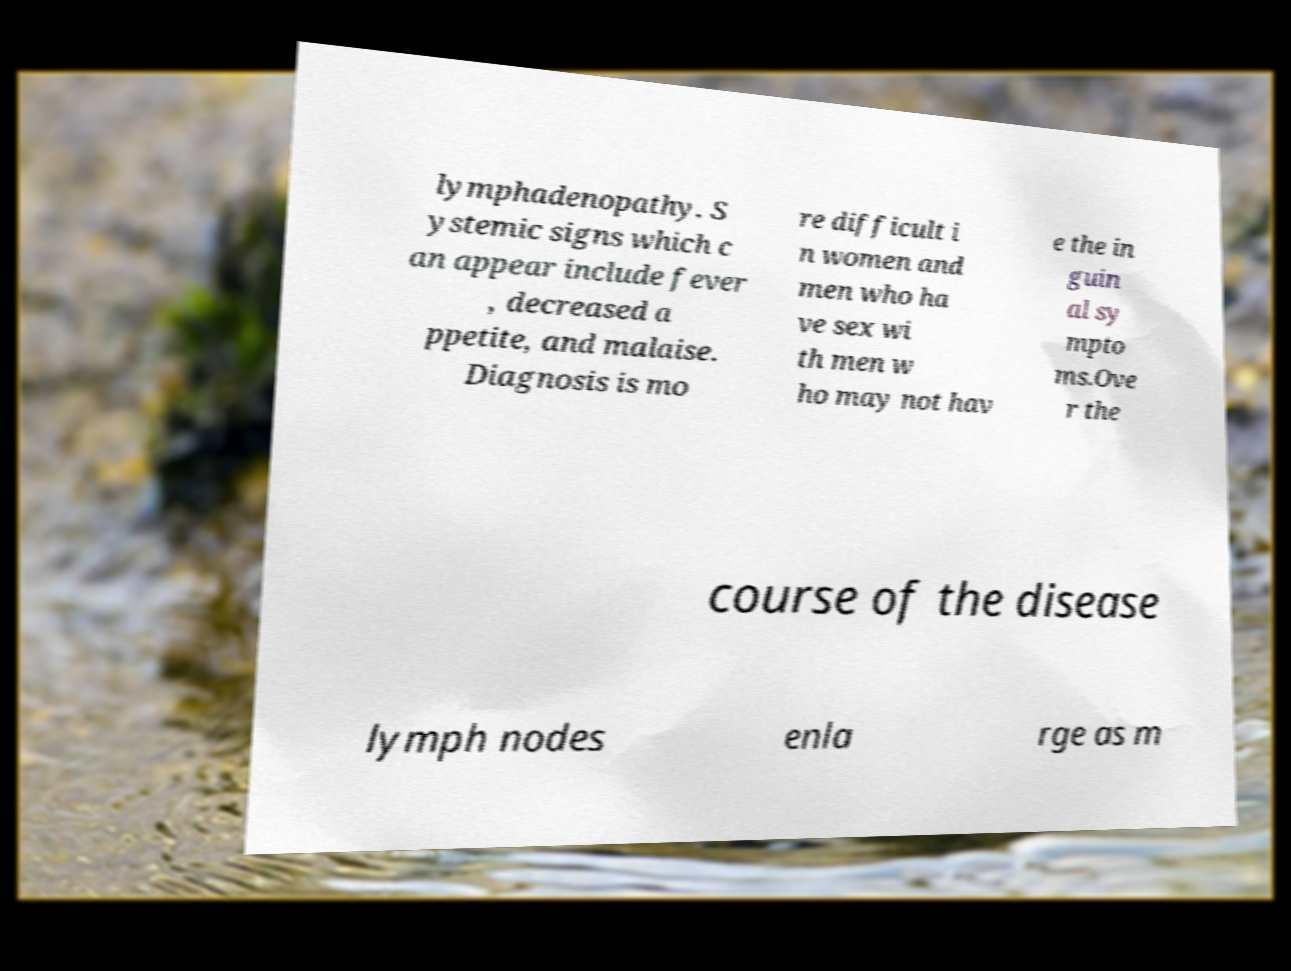I need the written content from this picture converted into text. Can you do that? lymphadenopathy. S ystemic signs which c an appear include fever , decreased a ppetite, and malaise. Diagnosis is mo re difficult i n women and men who ha ve sex wi th men w ho may not hav e the in guin al sy mpto ms.Ove r the course of the disease lymph nodes enla rge as m 